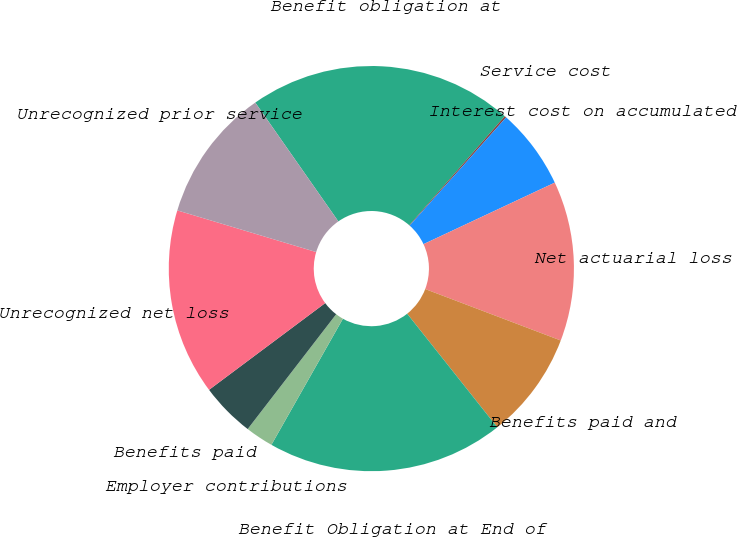Convert chart. <chart><loc_0><loc_0><loc_500><loc_500><pie_chart><fcel>Benefit obligation at<fcel>Service cost<fcel>Interest cost on accumulated<fcel>Net actuarial loss<fcel>Benefits paid and<fcel>Benefit Obligation at End of<fcel>Employer contributions<fcel>Benefits paid<fcel>Unrecognized net loss<fcel>Unrecognized prior service<nl><fcel>21.16%<fcel>0.14%<fcel>6.44%<fcel>12.75%<fcel>8.55%<fcel>18.89%<fcel>2.24%<fcel>4.34%<fcel>14.85%<fcel>10.65%<nl></chart> 